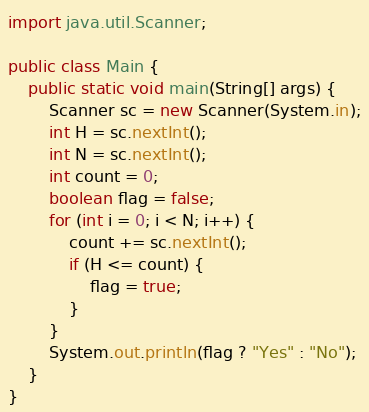Convert code to text. <code><loc_0><loc_0><loc_500><loc_500><_Java_>import java.util.Scanner;

public class Main {
    public static void main(String[] args) {
        Scanner sc = new Scanner(System.in);
        int H = sc.nextInt();
        int N = sc.nextInt();
        int count = 0;
        boolean flag = false;
        for (int i = 0; i < N; i++) {
            count += sc.nextInt();
            if (H <= count) {
                flag = true;
            }
        }
        System.out.println(flag ? "Yes" : "No");
    }
}</code> 